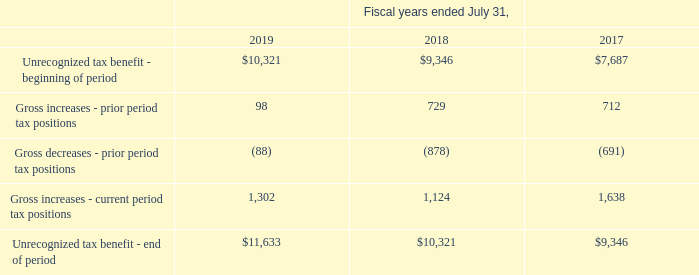Unrecognized Tax Benefits
Activity related to unrecognized tax benefits is as follows (in thousands):
During the year ended July 31, 2019, the Company’s unrecognized tax benefits increased by $1.3 million, primarily associated with the Company’s U.S. Federal and California R&D credits. As of July 31, 2019, the Company had unrecognized tax benefits of $6.2 million that, if recognized, would affect the Company’s effective tax rate. An estimate of the range of possible change within the next 12 months cannot be made at this time.
The Company, or one of its subsidiaries, files income taxes in the U.S. Federal jurisdiction and various state and foreign jurisdictions. If the Company utilizes net operating losses or tax credits in future years, the U.S. Federal, state and local, and non-U.S. tax authorities may examine the tax returns covering the period in which the net operating losses and tax credits arose. As a result, the Company’s tax returns in the U.S. and California remain open to examination from fiscal years 2002 through 2019. As of July 31, 2019, the Company has no income tax audits in progress in the U.S. or foreign jurisdictions.
What was the increase in unrecognized tax benefits in 2019? $1.3 million. What was the Gross increases - prior period tax positions in 2019, 2018 and 2017 respectively?
Answer scale should be: thousand. 98, 729, 712. What was the Gross decreases - prior period tax positions in 2019?
Answer scale should be: thousand. (88). In which year was Unrecognized tax benefit - end of period less than 10,000 thousands? Locate and analyze unrecognized tax benefit - beginning of period in row 3
answer: 2017. What was the average Unrecognized tax benefit - beginning of period for 2017-2019?
Answer scale should be: thousand. (11,633 + 10,321 + 9,346) / 3
Answer: 10433.33. What was the change in the Gross increases - prior period tax positions from 2018 to 2019?
Answer scale should be: thousand. 98 - 729
Answer: -631. 